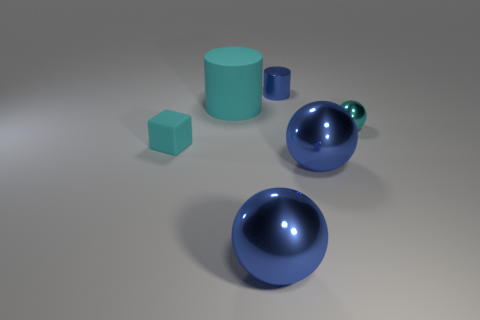There is a shiny cylinder; does it have the same size as the cyan matte thing on the left side of the big matte object?
Offer a terse response. Yes. How big is the thing that is both left of the small blue metal object and in front of the tiny rubber thing?
Your answer should be compact. Large. Are there any small balls made of the same material as the tiny blue cylinder?
Ensure brevity in your answer.  Yes. There is a big cyan rubber object; what shape is it?
Your response must be concise. Cylinder. Is the size of the blue metallic cylinder the same as the cyan shiny thing?
Keep it short and to the point. Yes. What number of other things are there of the same shape as the small blue metallic object?
Your answer should be compact. 1. The tiny thing left of the tiny blue metal cylinder has what shape?
Your response must be concise. Cube. There is a tiny metal object that is behind the cyan shiny object; is its shape the same as the matte thing that is in front of the cyan metal sphere?
Your answer should be very brief. No. Are there an equal number of rubber blocks that are behind the tiny blue object and purple shiny objects?
Your answer should be compact. Yes. Are there any other things that have the same size as the rubber cylinder?
Provide a short and direct response. Yes. 